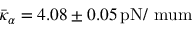Convert formula to latex. <formula><loc_0><loc_0><loc_500><loc_500>\bar { \kappa } _ { \alpha } = 4 . 0 8 \pm 0 . 0 5 \, { p N / \ m u m }</formula> 